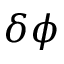Convert formula to latex. <formula><loc_0><loc_0><loc_500><loc_500>\delta \phi</formula> 